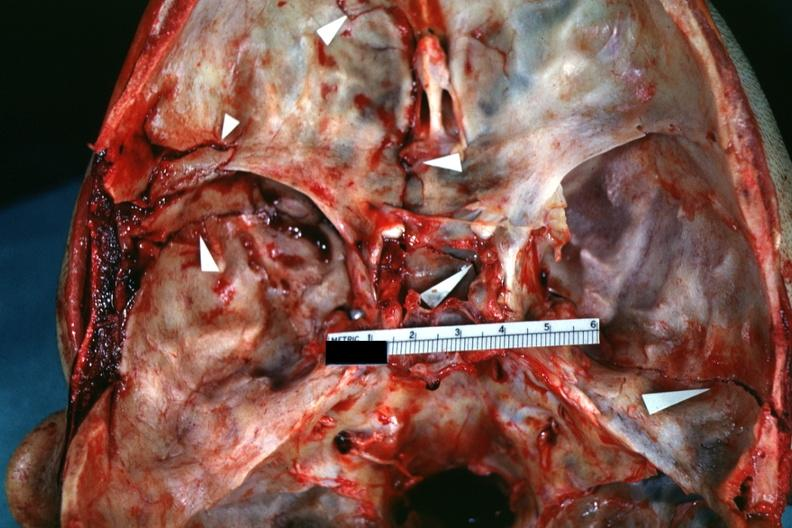s alpha smooth muscle actin immunohistochemical present?
Answer the question using a single word or phrase. No 